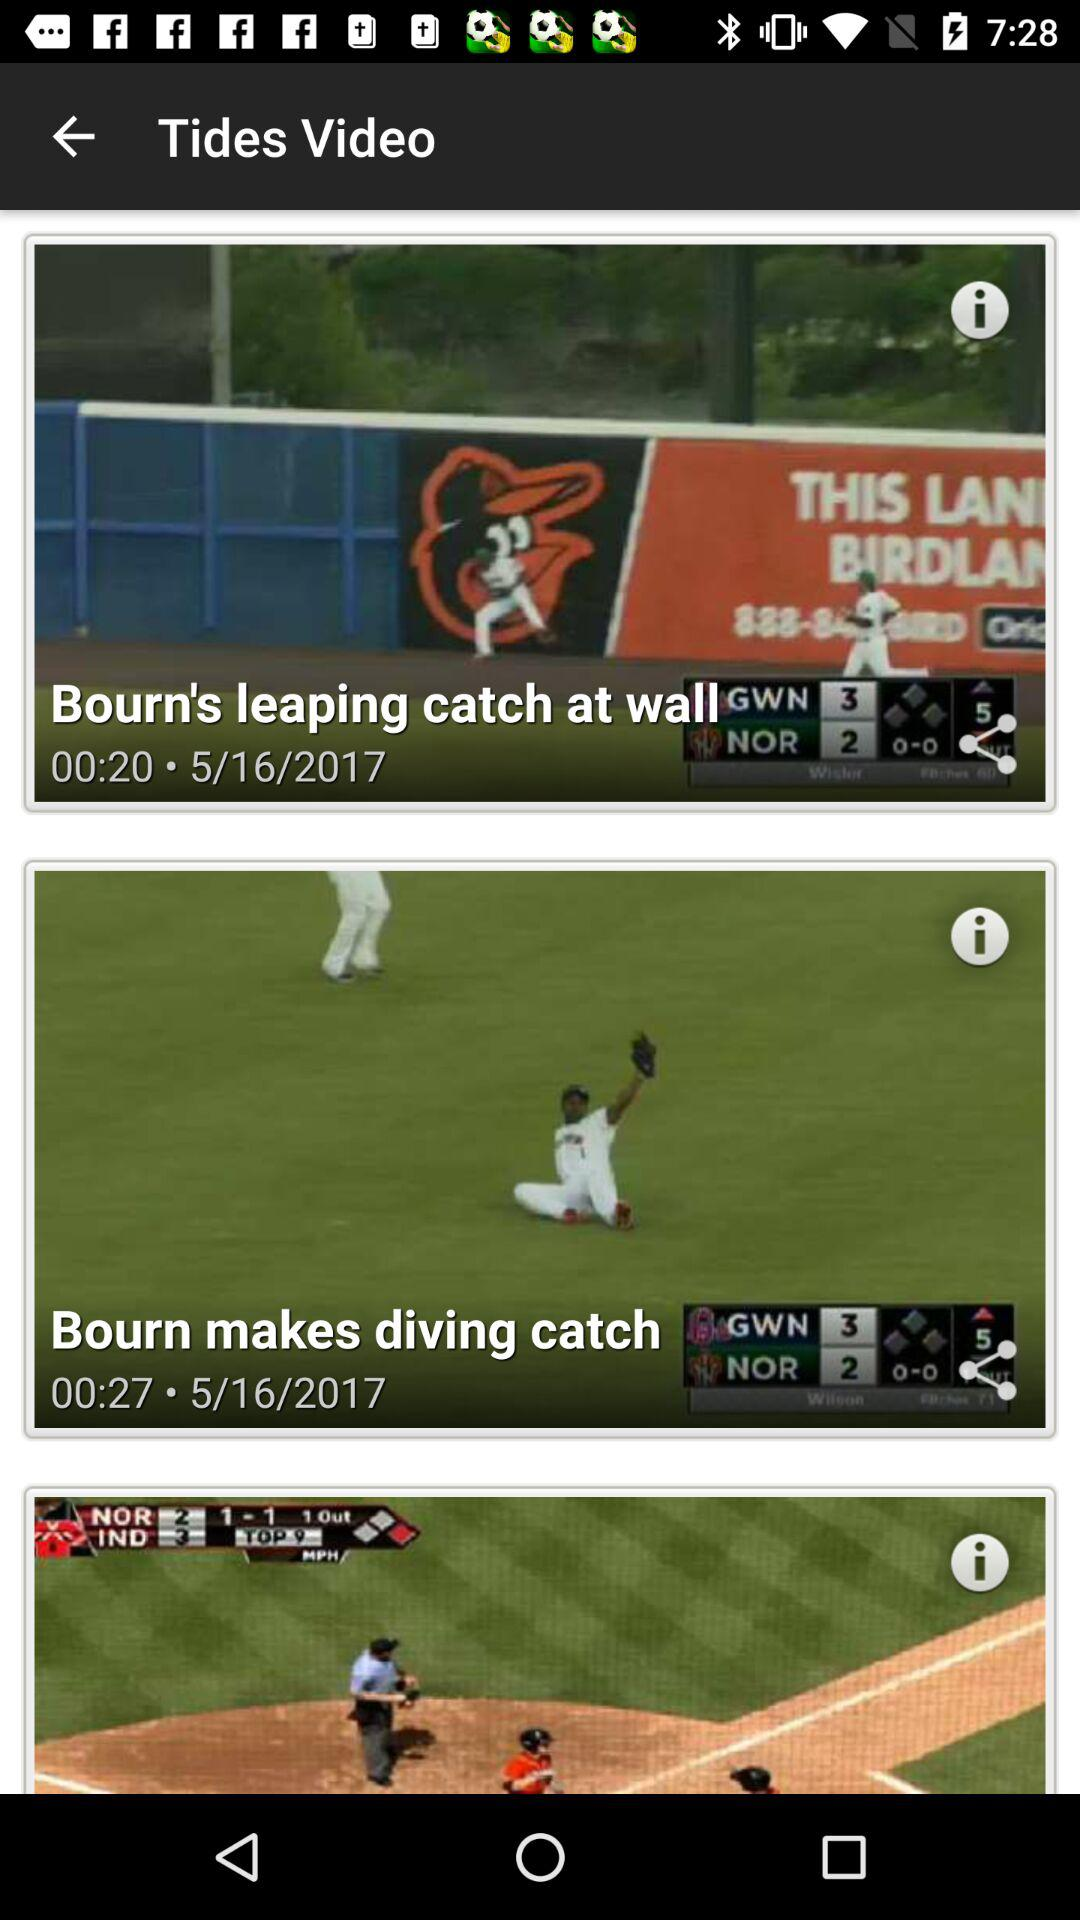At what date are videos uploaded? The date is May 16, 2017. 